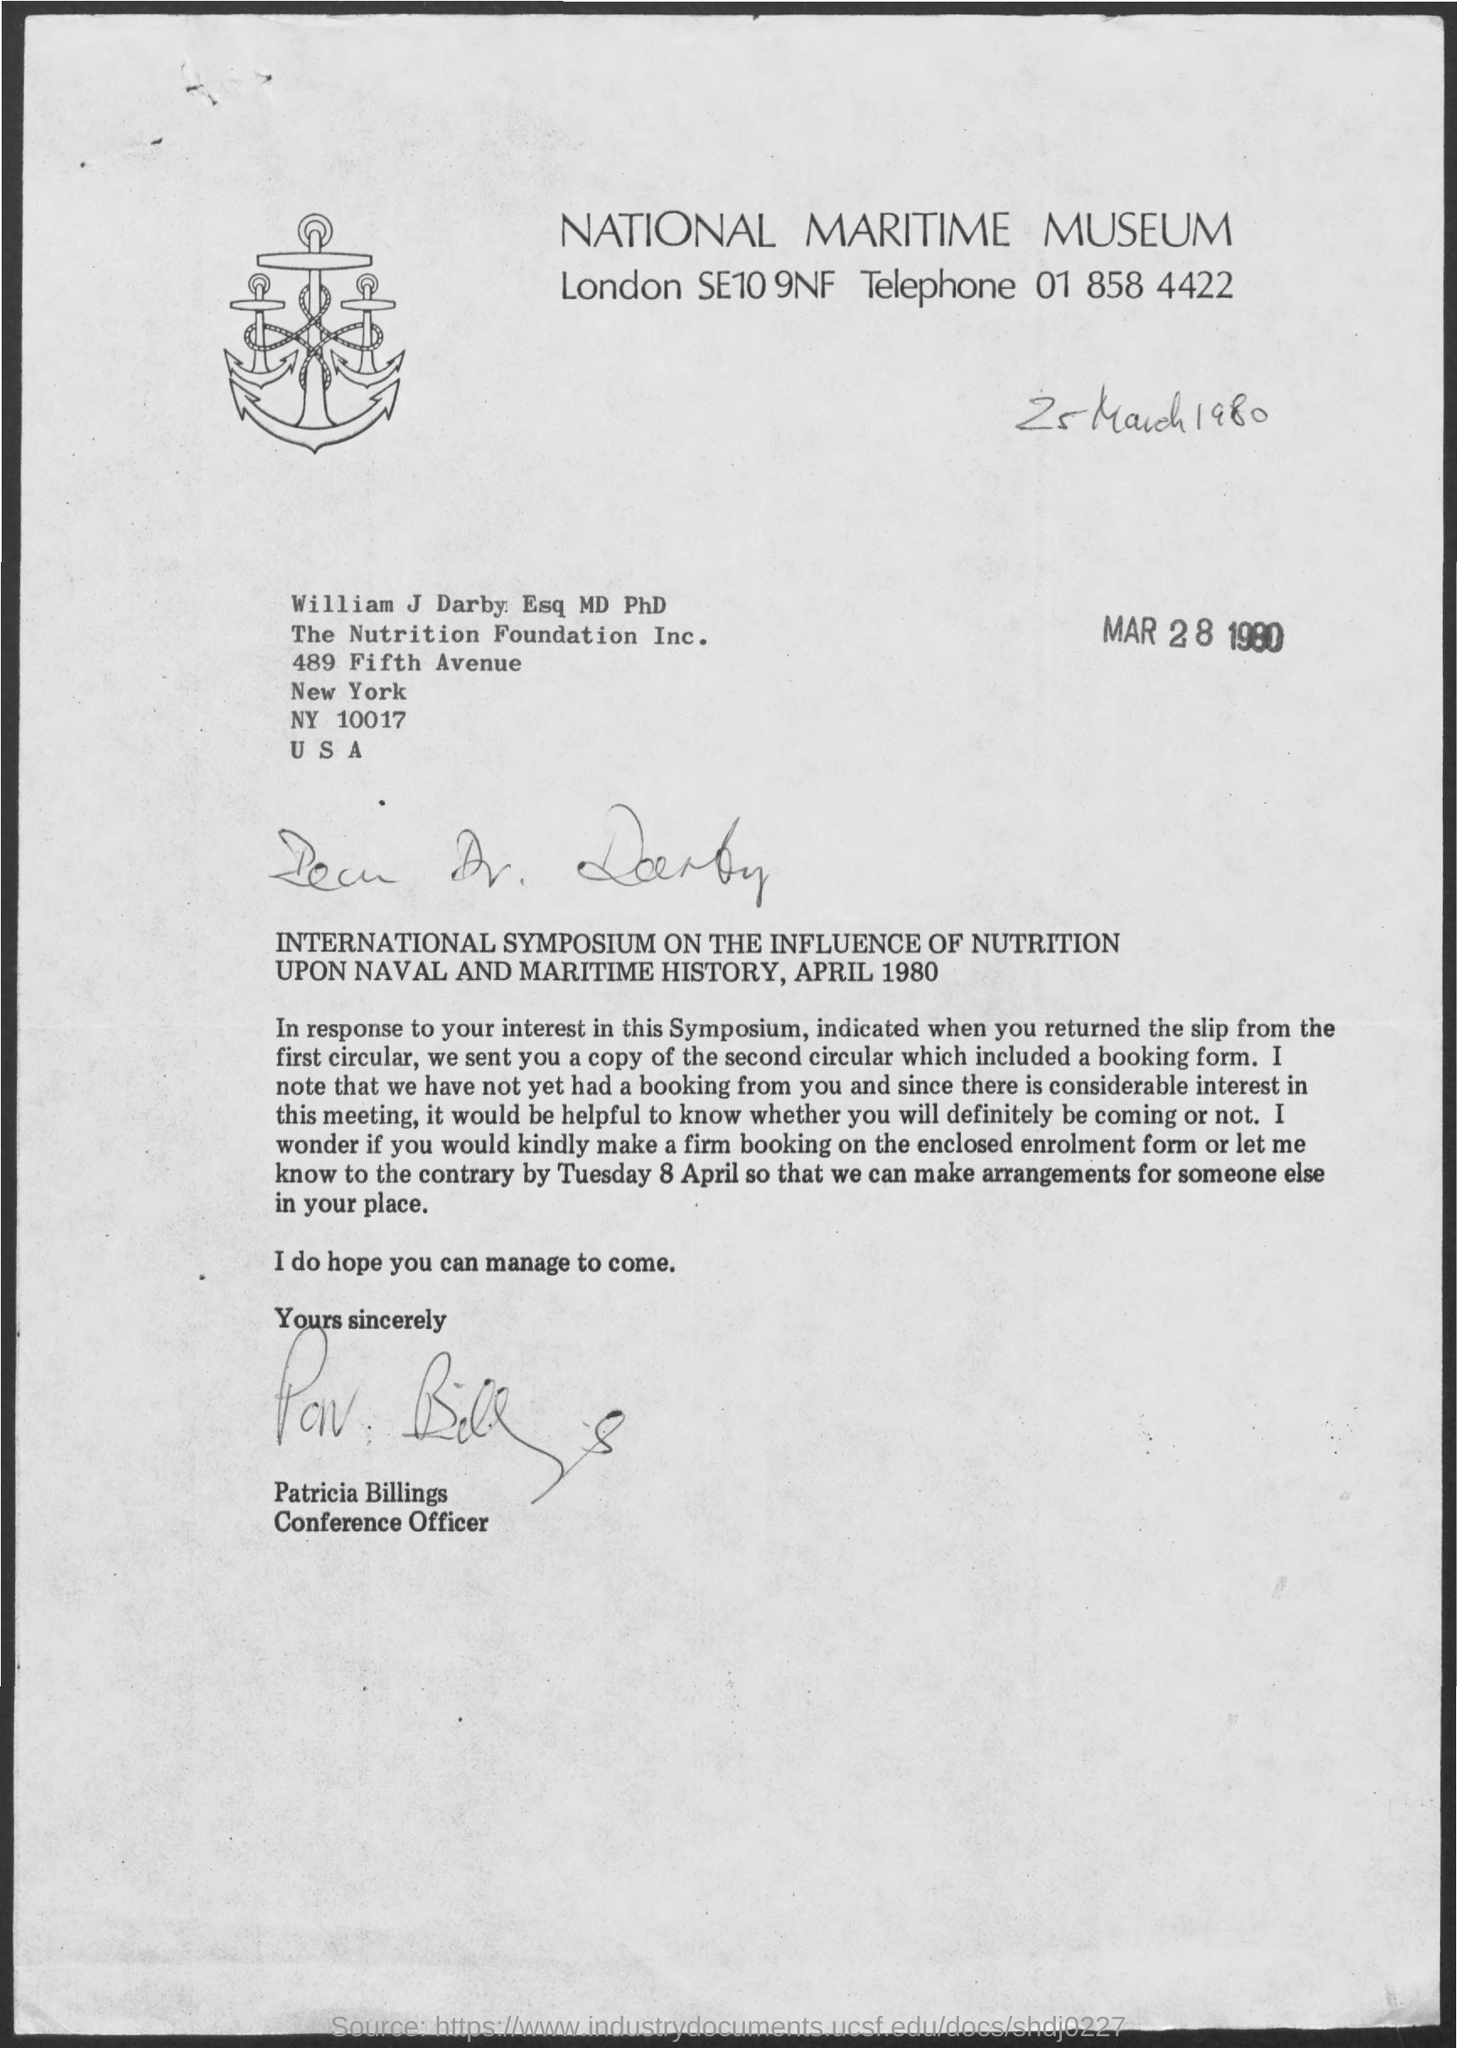What is the Telephone?
Ensure brevity in your answer.  01 858 4422. Who is this letter from?
Offer a very short reply. Patricia Billings. 